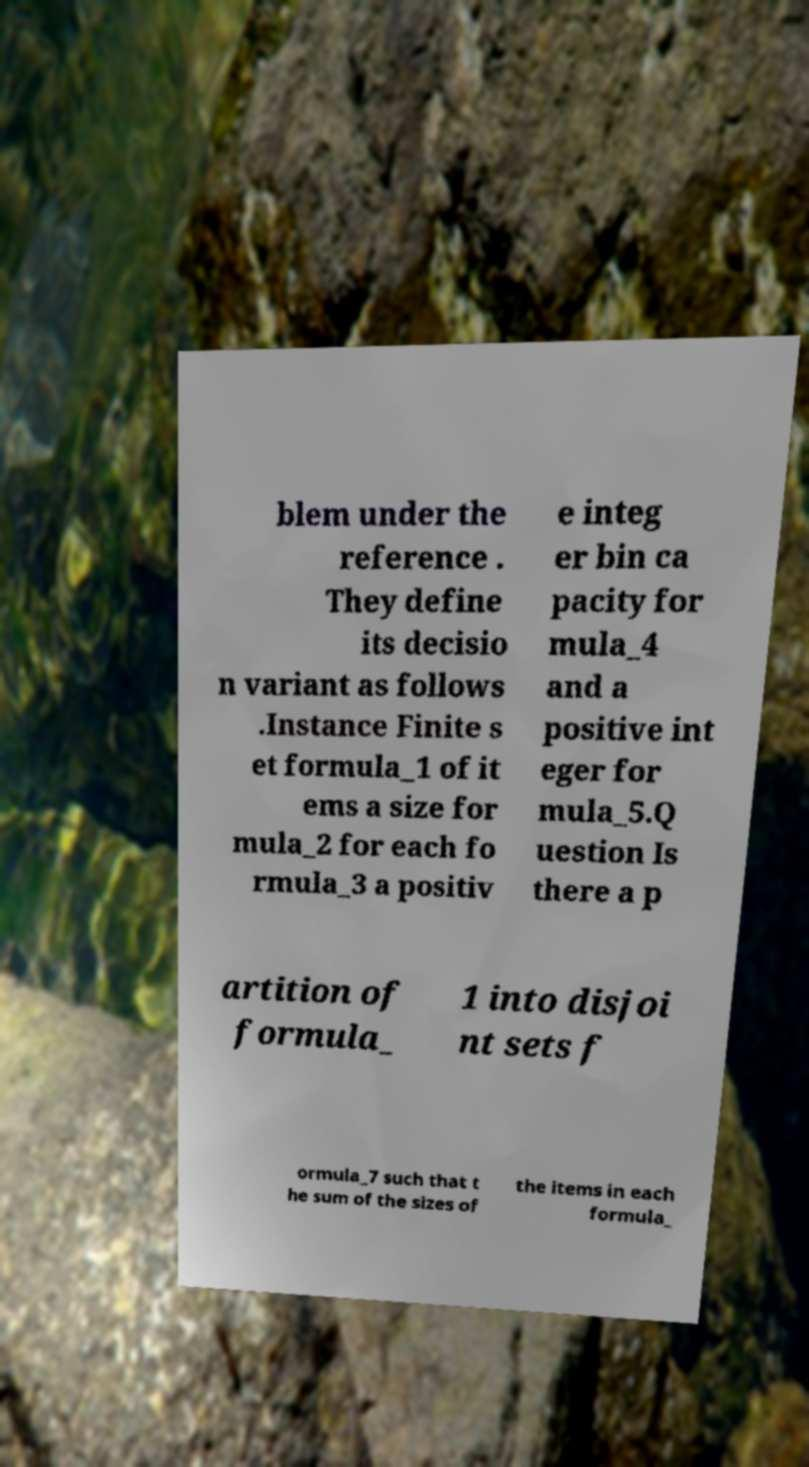There's text embedded in this image that I need extracted. Can you transcribe it verbatim? blem under the reference . They define its decisio n variant as follows .Instance Finite s et formula_1 of it ems a size for mula_2 for each fo rmula_3 a positiv e integ er bin ca pacity for mula_4 and a positive int eger for mula_5.Q uestion Is there a p artition of formula_ 1 into disjoi nt sets f ormula_7 such that t he sum of the sizes of the items in each formula_ 